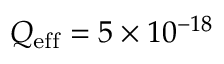Convert formula to latex. <formula><loc_0><loc_0><loc_500><loc_500>Q _ { e f f } = 5 \times 1 0 ^ { - 1 8 }</formula> 